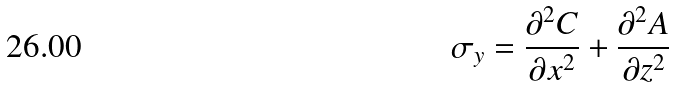<formula> <loc_0><loc_0><loc_500><loc_500>\sigma _ { y } = \frac { \partial ^ { 2 } C } { \partial x ^ { 2 } } + \frac { \partial ^ { 2 } A } { \partial z ^ { 2 } }</formula> 